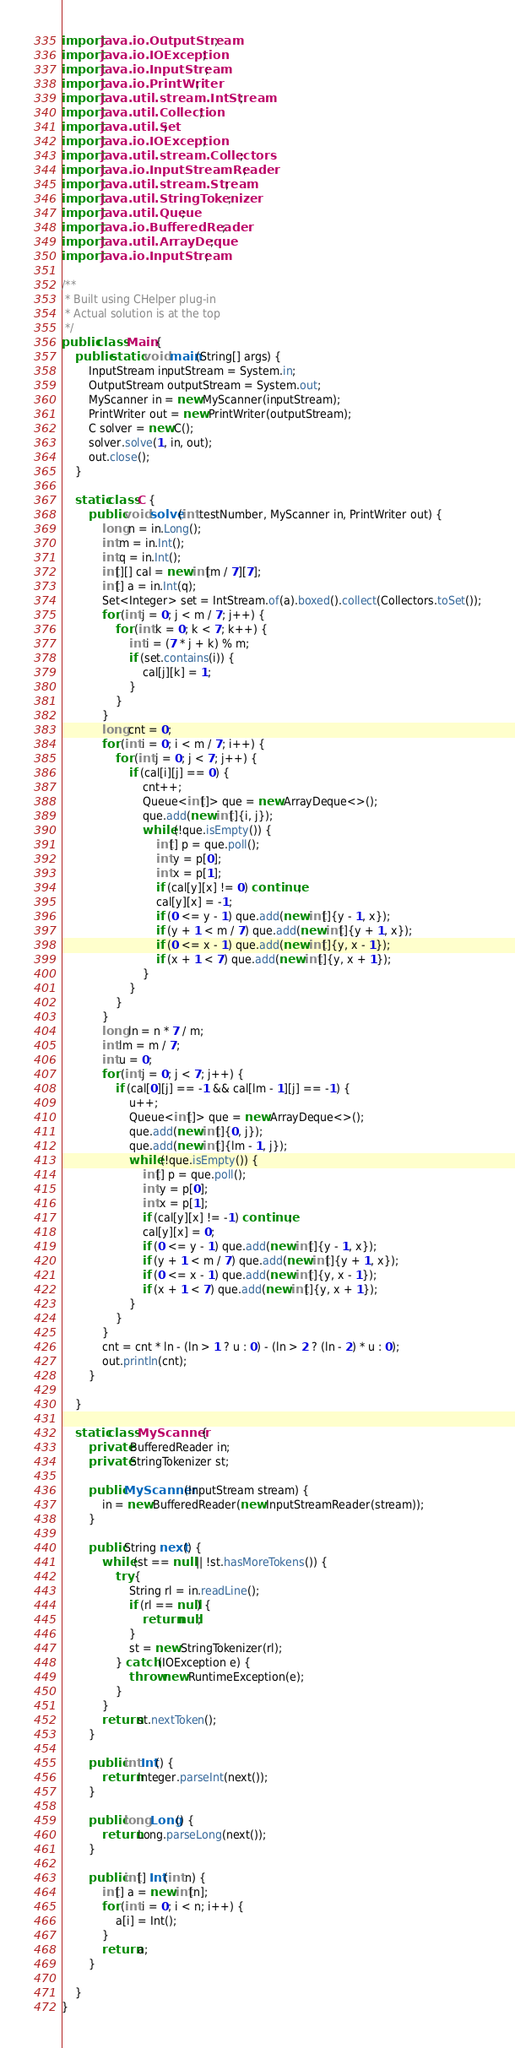Convert code to text. <code><loc_0><loc_0><loc_500><loc_500><_Java_>import java.io.OutputStream;
import java.io.IOException;
import java.io.InputStream;
import java.io.PrintWriter;
import java.util.stream.IntStream;
import java.util.Collection;
import java.util.Set;
import java.io.IOException;
import java.util.stream.Collectors;
import java.io.InputStreamReader;
import java.util.stream.Stream;
import java.util.StringTokenizer;
import java.util.Queue;
import java.io.BufferedReader;
import java.util.ArrayDeque;
import java.io.InputStream;

/**
 * Built using CHelper plug-in
 * Actual solution is at the top
 */
public class Main {
    public static void main(String[] args) {
        InputStream inputStream = System.in;
        OutputStream outputStream = System.out;
        MyScanner in = new MyScanner(inputStream);
        PrintWriter out = new PrintWriter(outputStream);
        C solver = new C();
        solver.solve(1, in, out);
        out.close();
    }

    static class C {
        public void solve(int testNumber, MyScanner in, PrintWriter out) {
            long n = in.Long();
            int m = in.Int();
            int q = in.Int();
            int[][] cal = new int[m / 7][7];
            int[] a = in.Int(q);
            Set<Integer> set = IntStream.of(a).boxed().collect(Collectors.toSet());
            for (int j = 0; j < m / 7; j++) {
                for (int k = 0; k < 7; k++) {
                    int i = (7 * j + k) % m;
                    if (set.contains(i)) {
                        cal[j][k] = 1;
                    }
                }
            }
            long cnt = 0;
            for (int i = 0; i < m / 7; i++) {
                for (int j = 0; j < 7; j++) {
                    if (cal[i][j] == 0) {
                        cnt++;
                        Queue<int[]> que = new ArrayDeque<>();
                        que.add(new int[]{i, j});
                        while (!que.isEmpty()) {
                            int[] p = que.poll();
                            int y = p[0];
                            int x = p[1];
                            if (cal[y][x] != 0) continue;
                            cal[y][x] = -1;
                            if (0 <= y - 1) que.add(new int[]{y - 1, x});
                            if (y + 1 < m / 7) que.add(new int[]{y + 1, x});
                            if (0 <= x - 1) que.add(new int[]{y, x - 1});
                            if (x + 1 < 7) que.add(new int[]{y, x + 1});
                        }
                    }
                }
            }
            long ln = n * 7 / m;
            int lm = m / 7;
            int u = 0;
            for (int j = 0; j < 7; j++) {
                if (cal[0][j] == -1 && cal[lm - 1][j] == -1) {
                    u++;
                    Queue<int[]> que = new ArrayDeque<>();
                    que.add(new int[]{0, j});
                    que.add(new int[]{lm - 1, j});
                    while (!que.isEmpty()) {
                        int[] p = que.poll();
                        int y = p[0];
                        int x = p[1];
                        if (cal[y][x] != -1) continue;
                        cal[y][x] = 0;
                        if (0 <= y - 1) que.add(new int[]{y - 1, x});
                        if (y + 1 < m / 7) que.add(new int[]{y + 1, x});
                        if (0 <= x - 1) que.add(new int[]{y, x - 1});
                        if (x + 1 < 7) que.add(new int[]{y, x + 1});
                    }
                }
            }
            cnt = cnt * ln - (ln > 1 ? u : 0) - (ln > 2 ? (ln - 2) * u : 0);
            out.println(cnt);
        }

    }

    static class MyScanner {
        private BufferedReader in;
        private StringTokenizer st;

        public MyScanner(InputStream stream) {
            in = new BufferedReader(new InputStreamReader(stream));
        }

        public String next() {
            while (st == null || !st.hasMoreTokens()) {
                try {
                    String rl = in.readLine();
                    if (rl == null) {
                        return null;
                    }
                    st = new StringTokenizer(rl);
                } catch (IOException e) {
                    throw new RuntimeException(e);
                }
            }
            return st.nextToken();
        }

        public int Int() {
            return Integer.parseInt(next());
        }

        public long Long() {
            return Long.parseLong(next());
        }

        public int[] Int(int n) {
            int[] a = new int[n];
            for (int i = 0; i < n; i++) {
                a[i] = Int();
            }
            return a;
        }

    }
}

</code> 